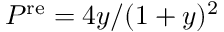<formula> <loc_0><loc_0><loc_500><loc_500>P ^ { r e } = 4 y / ( 1 + y ) ^ { 2 }</formula> 